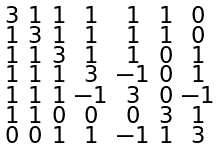Convert formula to latex. <formula><loc_0><loc_0><loc_500><loc_500>\begin{smallmatrix} 3 & 1 & 1 & 1 & 1 & 1 & 0 \\ 1 & 3 & 1 & 1 & 1 & 1 & 0 \\ 1 & 1 & 3 & 1 & 1 & 0 & 1 \\ 1 & 1 & 1 & 3 & - 1 & 0 & 1 \\ 1 & 1 & 1 & - 1 & 3 & 0 & - 1 \\ 1 & 1 & 0 & 0 & 0 & 3 & 1 \\ 0 & 0 & 1 & 1 & - 1 & 1 & 3 \end{smallmatrix}</formula> 